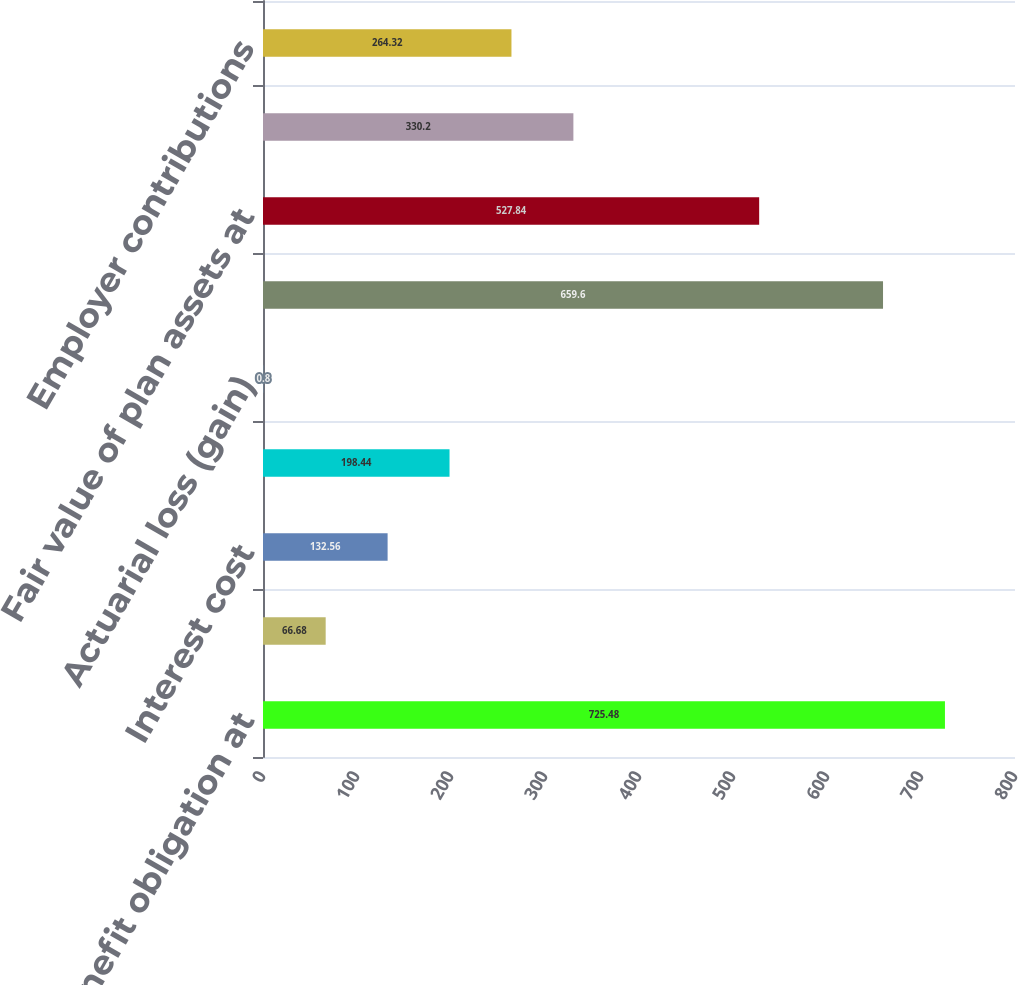<chart> <loc_0><loc_0><loc_500><loc_500><bar_chart><fcel>Benefit obligation at<fcel>Service cost<fcel>Interest cost<fcel>Benefits paid and other<fcel>Actuarial loss (gain)<fcel>Benefit obligation at end of<fcel>Fair value of plan assets at<fcel>Actual return on plan assets<fcel>Employer contributions<nl><fcel>725.48<fcel>66.68<fcel>132.56<fcel>198.44<fcel>0.8<fcel>659.6<fcel>527.84<fcel>330.2<fcel>264.32<nl></chart> 